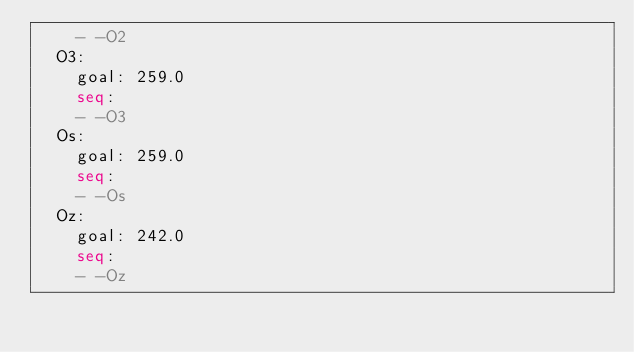Convert code to text. <code><loc_0><loc_0><loc_500><loc_500><_YAML_>    - -O2
  O3:
    goal: 259.0
    seq:
    - -O3
  Os:
    goal: 259.0
    seq:
    - -Os
  Oz:
    goal: 242.0
    seq:
    - -Oz
</code> 